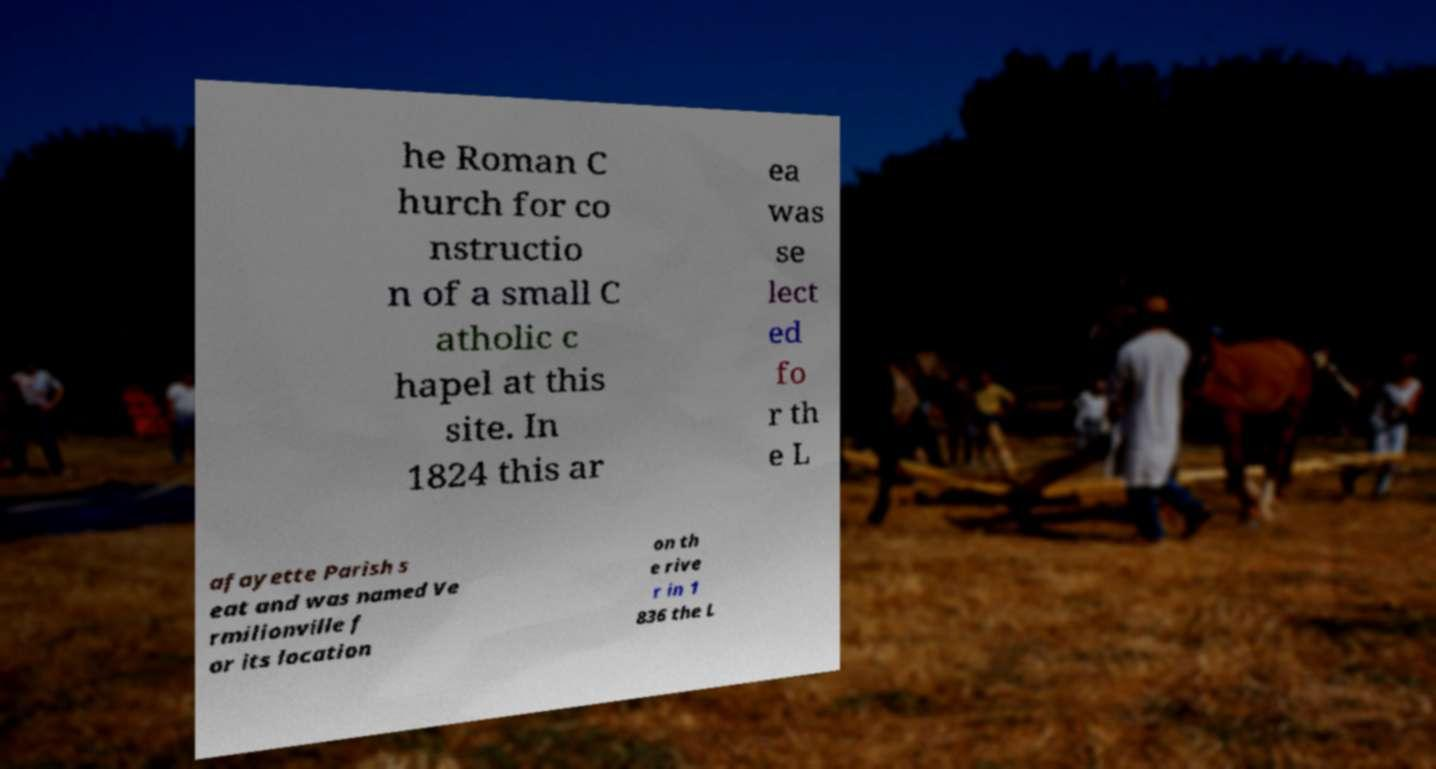There's text embedded in this image that I need extracted. Can you transcribe it verbatim? he Roman C hurch for co nstructio n of a small C atholic c hapel at this site. In 1824 this ar ea was se lect ed fo r th e L afayette Parish s eat and was named Ve rmilionville f or its location on th e rive r in 1 836 the L 